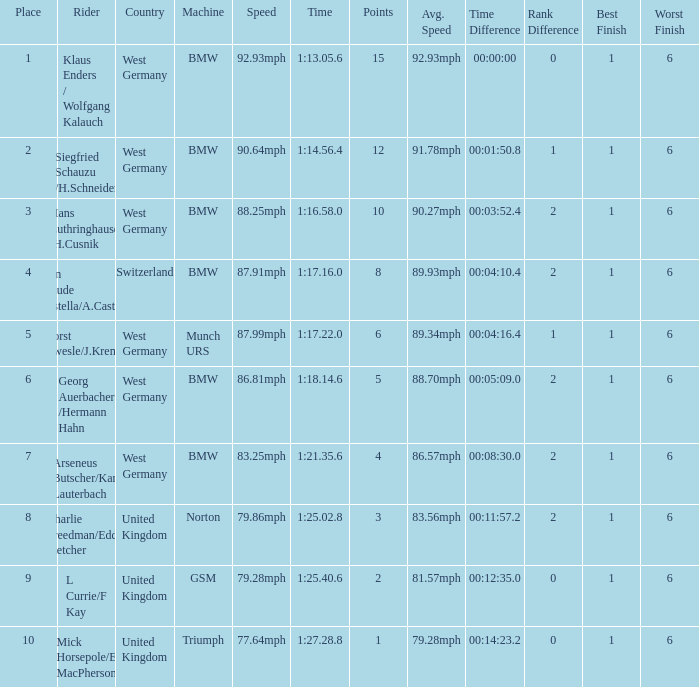Which places have points larger than 10? None. 